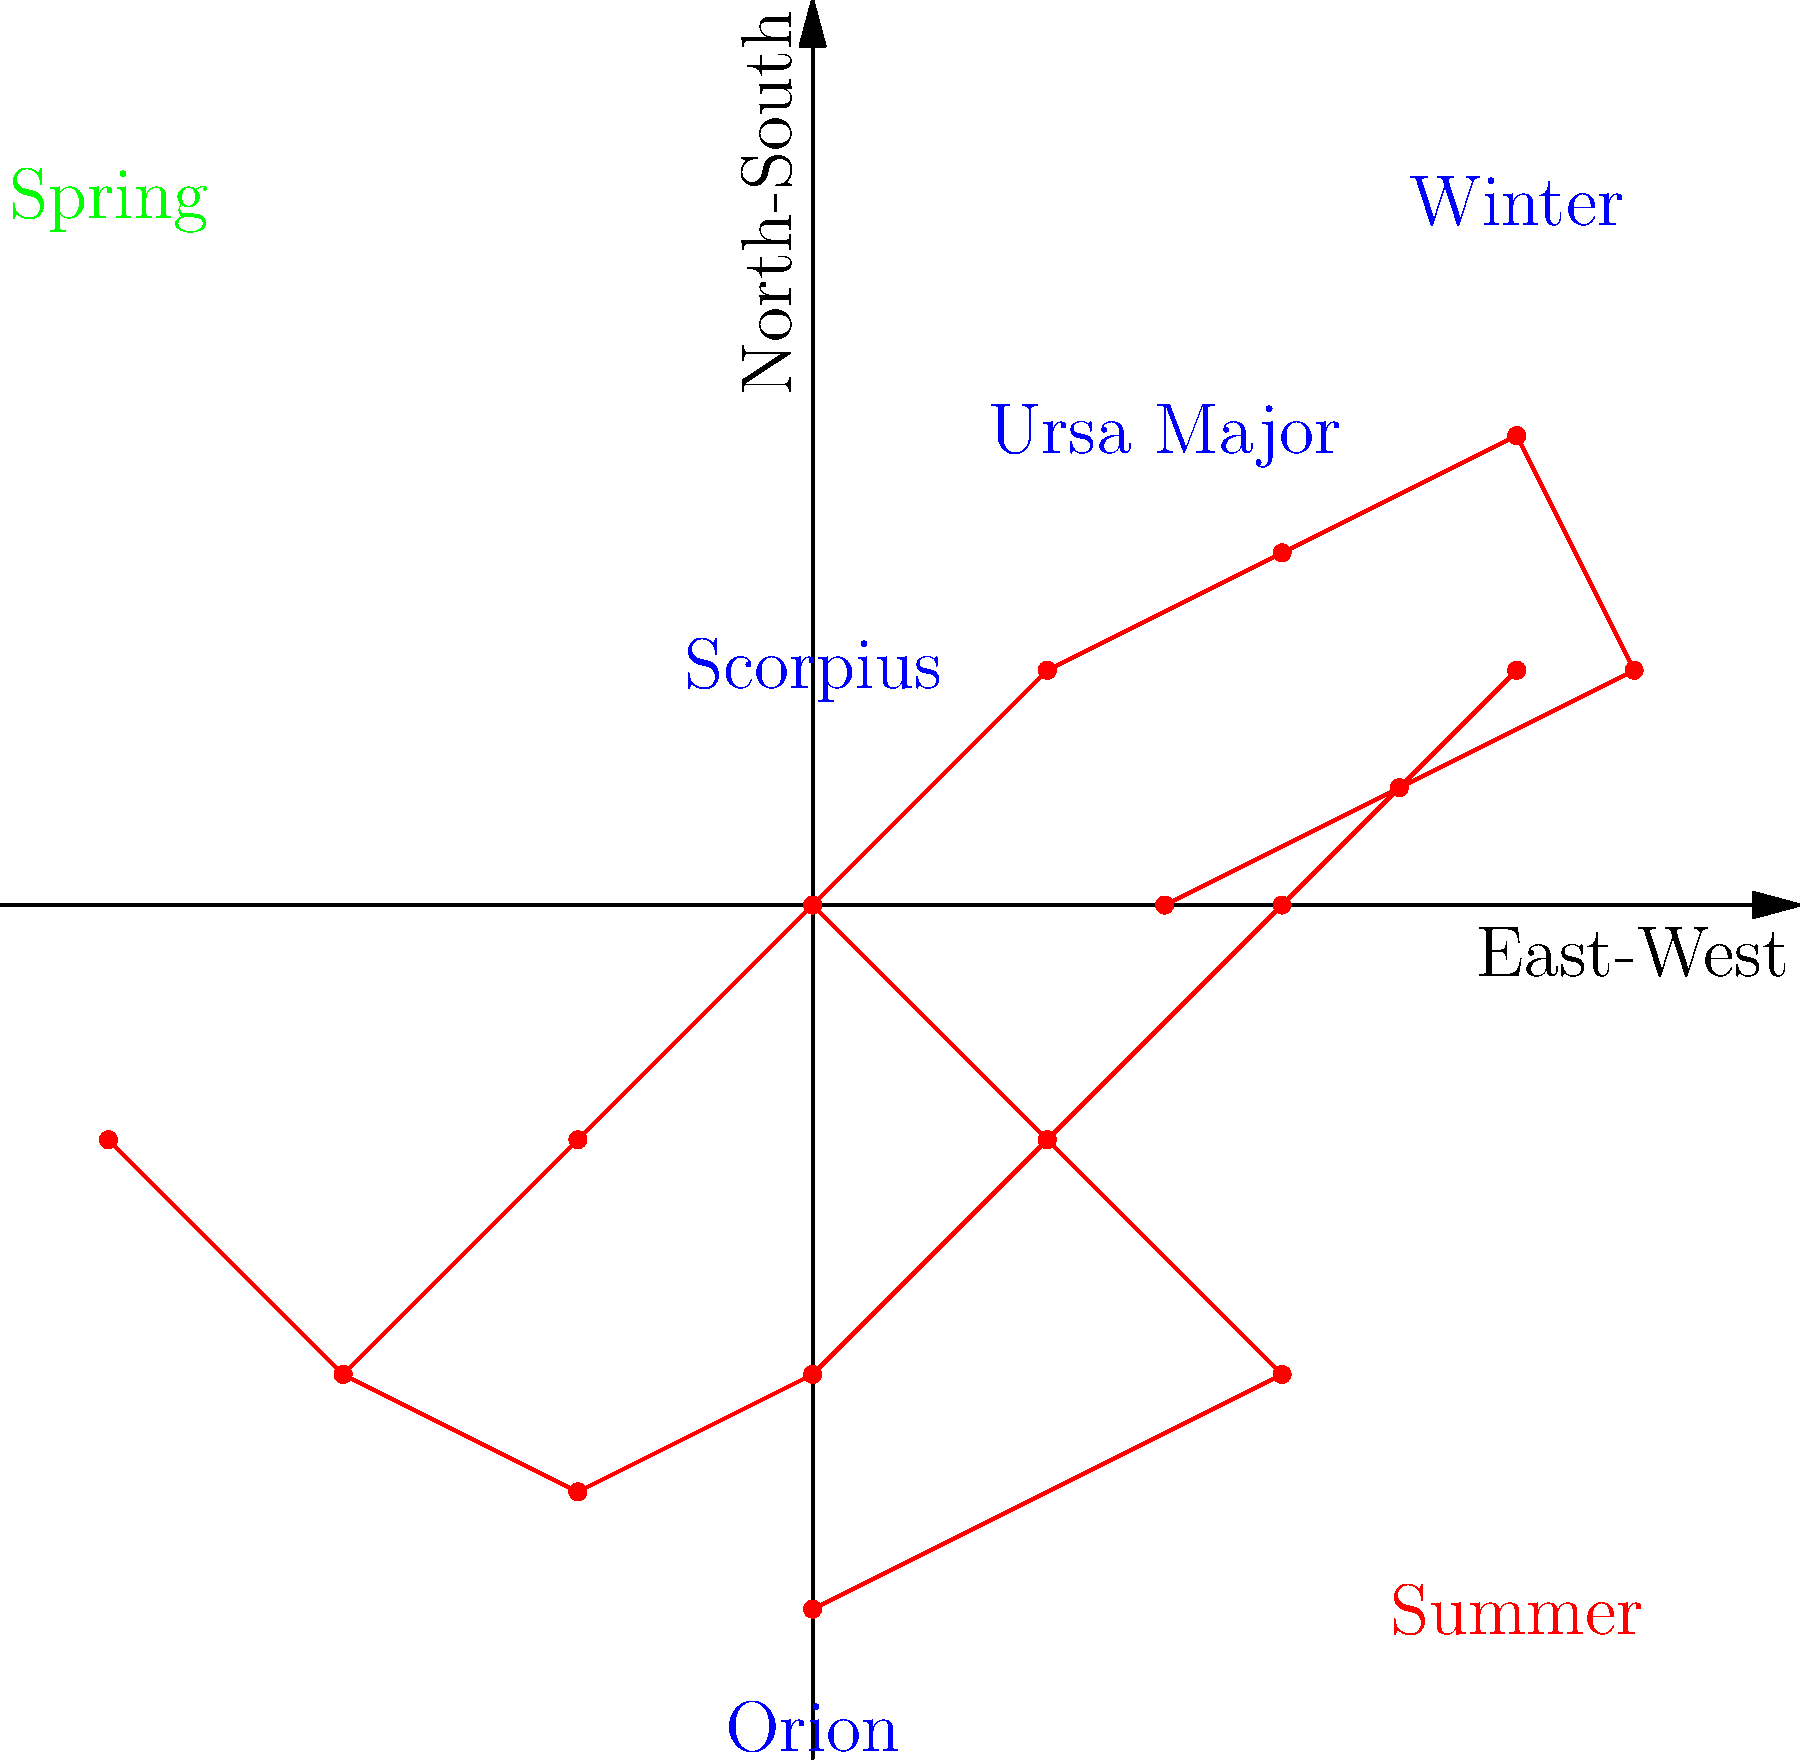In the star chart provided, which constellation is most likely to be visible during the summer months in the Northern Hemisphere of China? To determine which constellation is most visible during summer in the Northern Hemisphere of China, we need to consider the following steps:

1. Understand the seasonal visibility of constellations:
   - Different constellations are visible during different seasons due to Earth's orbit around the Sun.
   - In summer, we see constellations that are opposite to the Sun in the night sky.

2. Identify the constellations in the chart:
   - The chart shows three constellations: Ursa Major, Orion, and Scorpius.

3. Analyze the positions of the constellations:
   - Ursa Major is near the top of the chart, indicating it's visible in the northern sky.
   - Orion is in the middle-lower part of the chart, often associated with winter.
   - Scorpius is in the lower right, typically visible in summer evenings.

4. Consider the seasonal labels:
   - The chart labels "Summer" in the lower right corner, coinciding with Scorpius' position.

5. Apply knowledge of Chinese geography:
   - China is in the Northern Hemisphere, so summer constellations will be those visible in the southern sky during summer nights.

6. Conclude based on the information:
   - Scorpius, being in the southern part of the sky (lower part of the chart) and labeled near "Summer," is the constellation most likely to be visible during summer months in the Northern Hemisphere of China.
Answer: Scorpius 